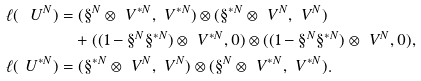Convert formula to latex. <formula><loc_0><loc_0><loc_500><loc_500>\ell ( { \ U } ^ { N } ) & = ( { \S } ^ { N } \otimes { \ V } ^ { * N } , { \ V } ^ { * N } ) \otimes ( { \S } ^ { * N } \otimes { \ V } ^ { N } , { \ V } ^ { N } ) \\ & \quad + ( ( 1 - { \S } ^ { N } { \S } ^ { * N } ) \otimes { \ V } ^ { * N } , 0 ) \otimes ( ( 1 - { \S } ^ { N } { \S } ^ { * N } ) \otimes { \ V } ^ { N } , 0 ) , \\ \ell ( { \ U } ^ { * N } ) & = ( { \S } ^ { * N } \otimes { \ V } ^ { N } , { \ V } ^ { N } ) \otimes ( { \S } ^ { N } \otimes { \ V } ^ { * N } , { \ V } ^ { * N } ) .</formula> 